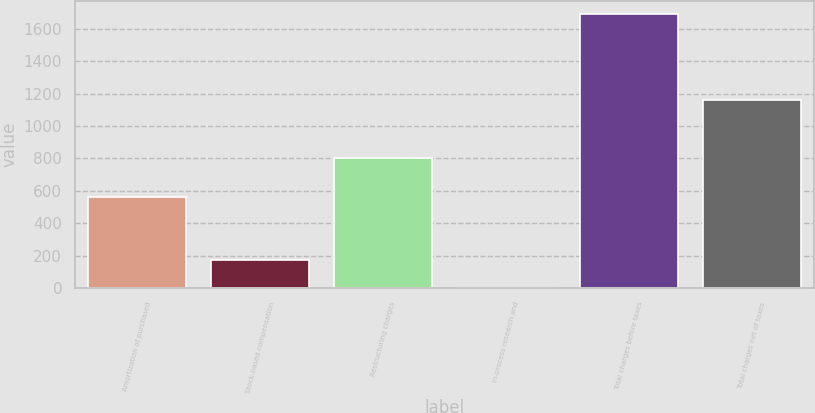Convert chart. <chart><loc_0><loc_0><loc_500><loc_500><bar_chart><fcel>Amortization of purchased<fcel>Stock-based compensation<fcel>Restructuring charges<fcel>In-process research and<fcel>Total charges before taxes<fcel>Total charges net of taxes<nl><fcel>563<fcel>169.8<fcel>800<fcel>1<fcel>1689<fcel>1157<nl></chart> 